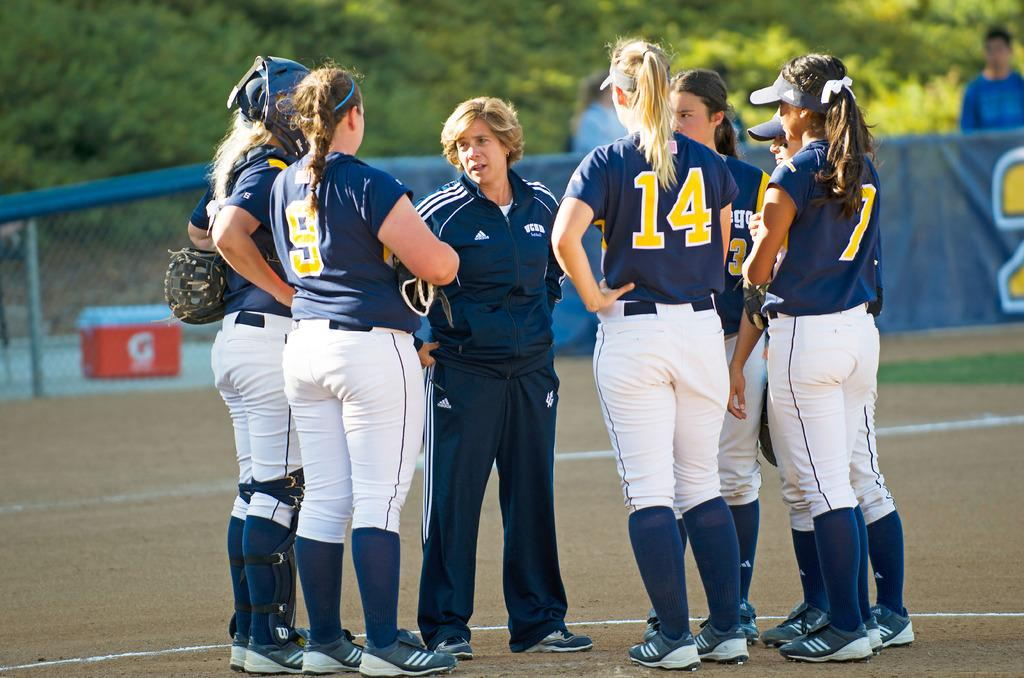<image>
Give a short and clear explanation of the subsequent image. The girl's baseball team members are on the field talking to their coach, some have #'s on the shirts like 9, 14, and 7. 